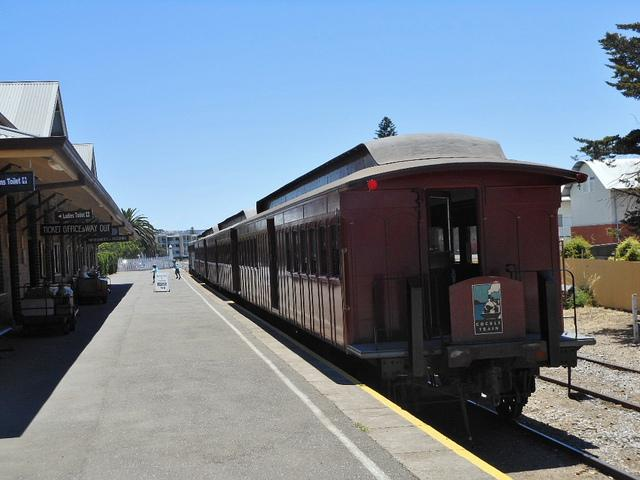What might the red light mean? stop 